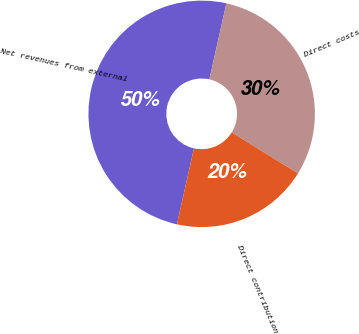<chart> <loc_0><loc_0><loc_500><loc_500><pie_chart><fcel>Net revenues from external<fcel>Direct costs<fcel>Direct contribution<nl><fcel>50.0%<fcel>30.31%<fcel>19.69%<nl></chart> 